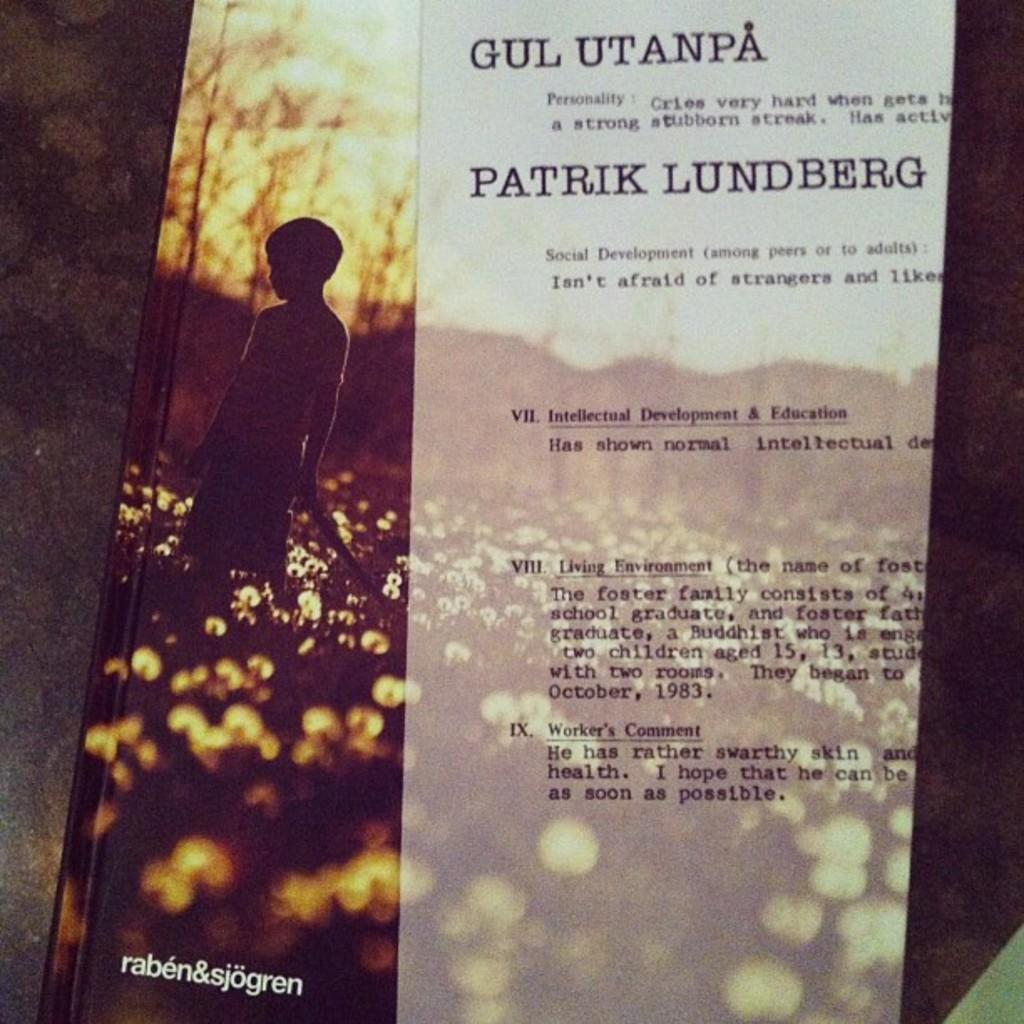Provide a one-sentence caption for the provided image. Cover of a book showing a boy in a field and the words "raben&sjogren" on the bottom. 